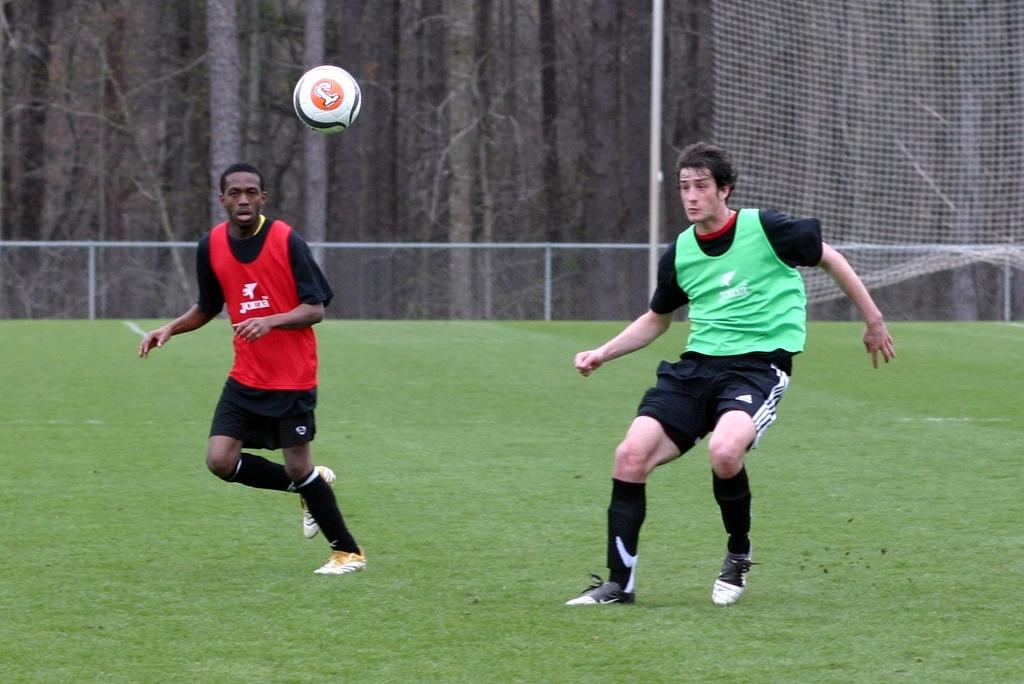How many people are present in the image? There are two persons in the image. What object can be seen in the image that is commonly used in sports? There is a ball in the image. What type of barrier is visible in the image? There is fencing in the image. What sports equipment is present in the image? There is a sports net in the image. What can be seen in the background of the image? There are trees in the background of the image. What type of cars are parked near the sports net in the image? There are no cars present in the image; it only features two persons, a ball, fencing, a sports net, and trees in the background. 